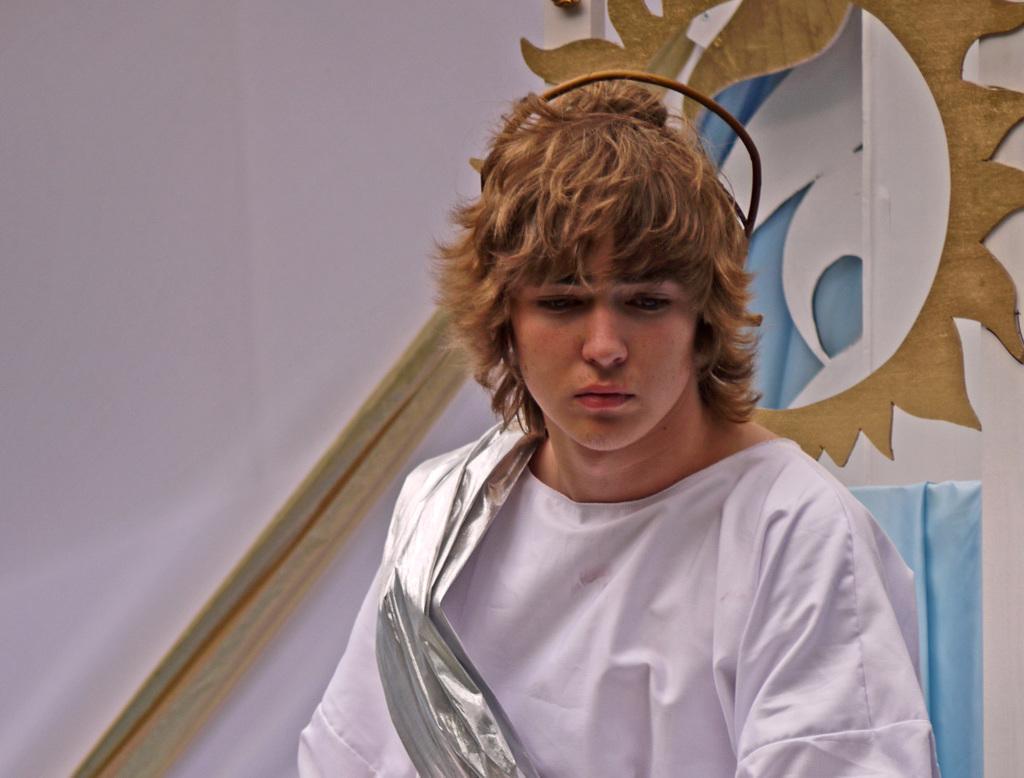Please provide a concise description of this image. In this image we can see there is a person wearing white clothes is standing. In the background there is a wall. 